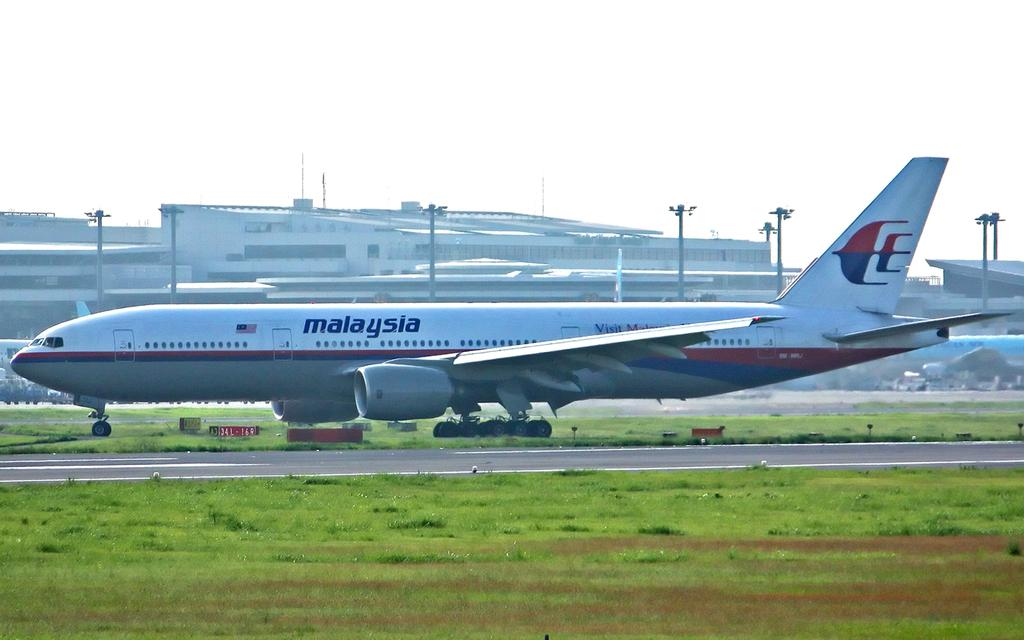<image>
Render a clear and concise summary of the photo. a plan that has the country of Malaysia written on the side 